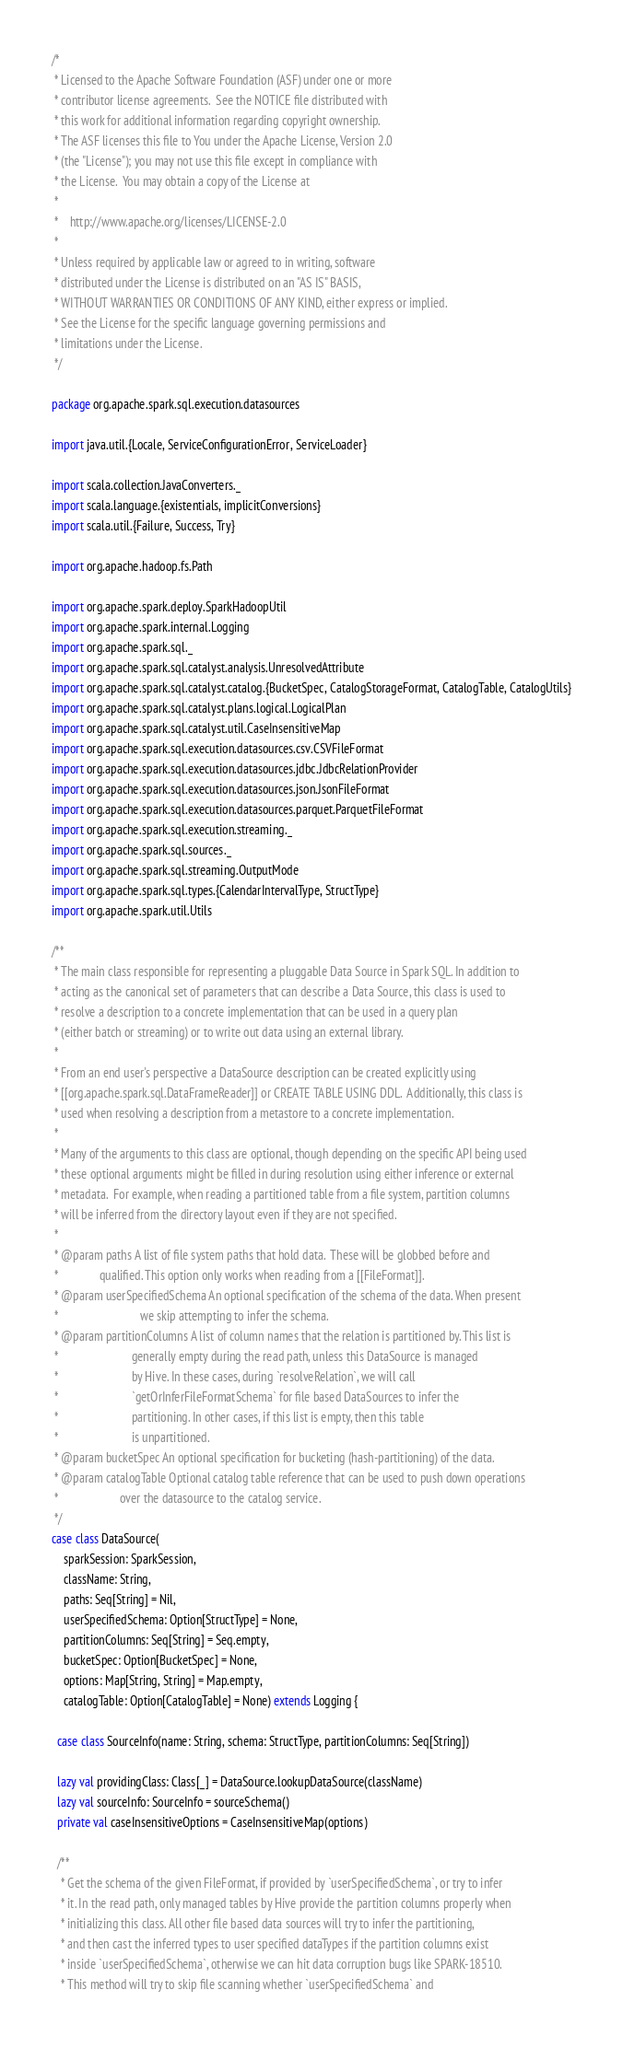Convert code to text. <code><loc_0><loc_0><loc_500><loc_500><_Scala_>/*
 * Licensed to the Apache Software Foundation (ASF) under one or more
 * contributor license agreements.  See the NOTICE file distributed with
 * this work for additional information regarding copyright ownership.
 * The ASF licenses this file to You under the Apache License, Version 2.0
 * (the "License"); you may not use this file except in compliance with
 * the License.  You may obtain a copy of the License at
 *
 *    http://www.apache.org/licenses/LICENSE-2.0
 *
 * Unless required by applicable law or agreed to in writing, software
 * distributed under the License is distributed on an "AS IS" BASIS,
 * WITHOUT WARRANTIES OR CONDITIONS OF ANY KIND, either express or implied.
 * See the License for the specific language governing permissions and
 * limitations under the License.
 */

package org.apache.spark.sql.execution.datasources

import java.util.{Locale, ServiceConfigurationError, ServiceLoader}

import scala.collection.JavaConverters._
import scala.language.{existentials, implicitConversions}
import scala.util.{Failure, Success, Try}

import org.apache.hadoop.fs.Path

import org.apache.spark.deploy.SparkHadoopUtil
import org.apache.spark.internal.Logging
import org.apache.spark.sql._
import org.apache.spark.sql.catalyst.analysis.UnresolvedAttribute
import org.apache.spark.sql.catalyst.catalog.{BucketSpec, CatalogStorageFormat, CatalogTable, CatalogUtils}
import org.apache.spark.sql.catalyst.plans.logical.LogicalPlan
import org.apache.spark.sql.catalyst.util.CaseInsensitiveMap
import org.apache.spark.sql.execution.datasources.csv.CSVFileFormat
import org.apache.spark.sql.execution.datasources.jdbc.JdbcRelationProvider
import org.apache.spark.sql.execution.datasources.json.JsonFileFormat
import org.apache.spark.sql.execution.datasources.parquet.ParquetFileFormat
import org.apache.spark.sql.execution.streaming._
import org.apache.spark.sql.sources._
import org.apache.spark.sql.streaming.OutputMode
import org.apache.spark.sql.types.{CalendarIntervalType, StructType}
import org.apache.spark.util.Utils

/**
 * The main class responsible for representing a pluggable Data Source in Spark SQL. In addition to
 * acting as the canonical set of parameters that can describe a Data Source, this class is used to
 * resolve a description to a concrete implementation that can be used in a query plan
 * (either batch or streaming) or to write out data using an external library.
 *
 * From an end user's perspective a DataSource description can be created explicitly using
 * [[org.apache.spark.sql.DataFrameReader]] or CREATE TABLE USING DDL.  Additionally, this class is
 * used when resolving a description from a metastore to a concrete implementation.
 *
 * Many of the arguments to this class are optional, though depending on the specific API being used
 * these optional arguments might be filled in during resolution using either inference or external
 * metadata.  For example, when reading a partitioned table from a file system, partition columns
 * will be inferred from the directory layout even if they are not specified.
 *
 * @param paths A list of file system paths that hold data.  These will be globbed before and
 *              qualified. This option only works when reading from a [[FileFormat]].
 * @param userSpecifiedSchema An optional specification of the schema of the data. When present
 *                            we skip attempting to infer the schema.
 * @param partitionColumns A list of column names that the relation is partitioned by. This list is
 *                         generally empty during the read path, unless this DataSource is managed
 *                         by Hive. In these cases, during `resolveRelation`, we will call
 *                         `getOrInferFileFormatSchema` for file based DataSources to infer the
 *                         partitioning. In other cases, if this list is empty, then this table
 *                         is unpartitioned.
 * @param bucketSpec An optional specification for bucketing (hash-partitioning) of the data.
 * @param catalogTable Optional catalog table reference that can be used to push down operations
 *                     over the datasource to the catalog service.
 */
case class DataSource(
    sparkSession: SparkSession,
    className: String,
    paths: Seq[String] = Nil,
    userSpecifiedSchema: Option[StructType] = None,
    partitionColumns: Seq[String] = Seq.empty,
    bucketSpec: Option[BucketSpec] = None,
    options: Map[String, String] = Map.empty,
    catalogTable: Option[CatalogTable] = None) extends Logging {

  case class SourceInfo(name: String, schema: StructType, partitionColumns: Seq[String])

  lazy val providingClass: Class[_] = DataSource.lookupDataSource(className)
  lazy val sourceInfo: SourceInfo = sourceSchema()
  private val caseInsensitiveOptions = CaseInsensitiveMap(options)

  /**
   * Get the schema of the given FileFormat, if provided by `userSpecifiedSchema`, or try to infer
   * it. In the read path, only managed tables by Hive provide the partition columns properly when
   * initializing this class. All other file based data sources will try to infer the partitioning,
   * and then cast the inferred types to user specified dataTypes if the partition columns exist
   * inside `userSpecifiedSchema`, otherwise we can hit data corruption bugs like SPARK-18510.
   * This method will try to skip file scanning whether `userSpecifiedSchema` and</code> 